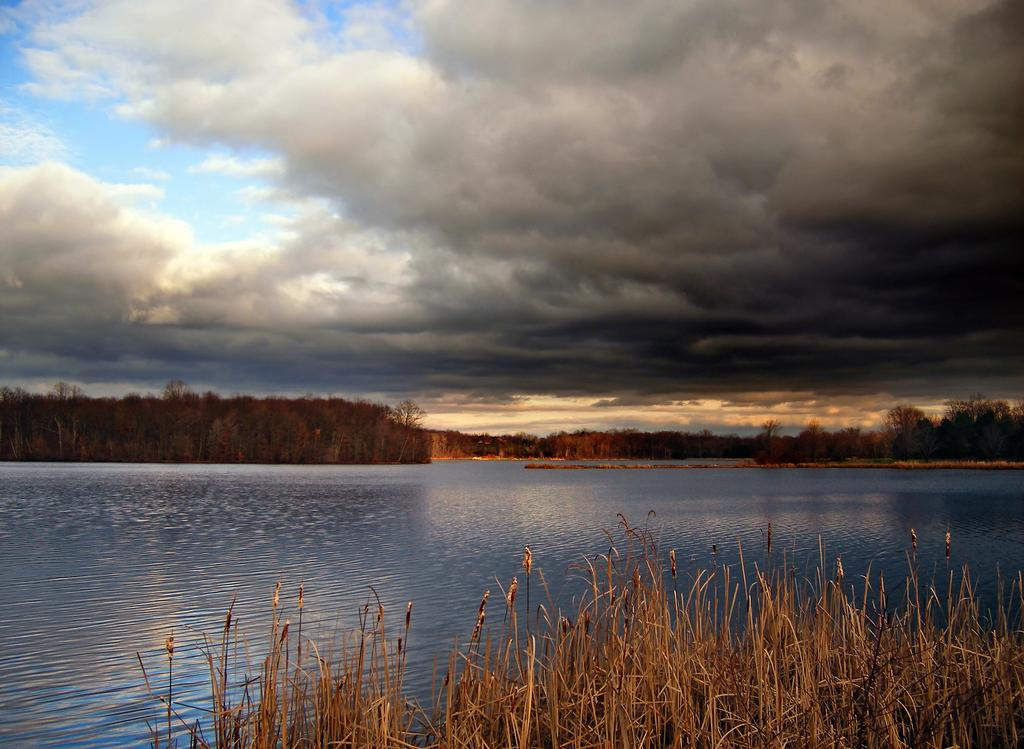What is the primary element that is flowing in the image? There is water flowing in the image. What type of vegetation can be seen in the image? There is dried grass in the image. What other natural elements are present in the image? There are trees in the image. What is visible in the sky in the image? There are clouds in the sky in the image. How many ducks are swimming in the water in the image? There are no ducks present in the image; it only features water flowing. What color is the sky in the image? The provided facts do not mention the color of the sky, only that there are clouds visible. 